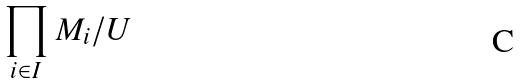<formula> <loc_0><loc_0><loc_500><loc_500>\prod _ { i \in I } M _ { i } / U</formula> 